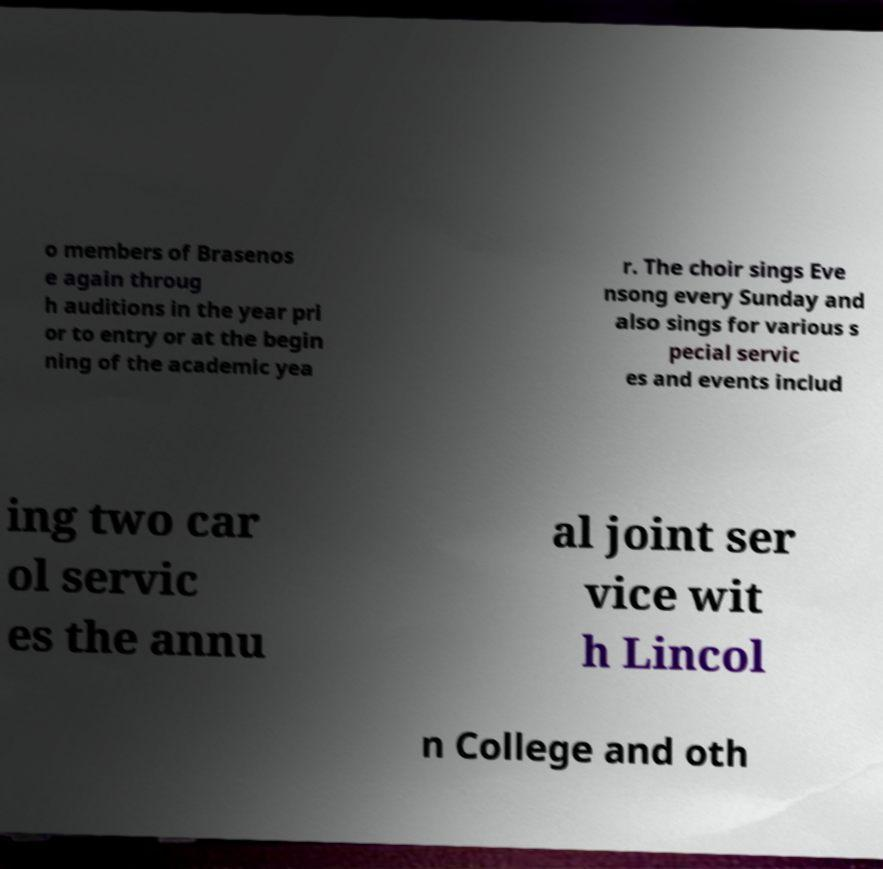I need the written content from this picture converted into text. Can you do that? o members of Brasenos e again throug h auditions in the year pri or to entry or at the begin ning of the academic yea r. The choir sings Eve nsong every Sunday and also sings for various s pecial servic es and events includ ing two car ol servic es the annu al joint ser vice wit h Lincol n College and oth 